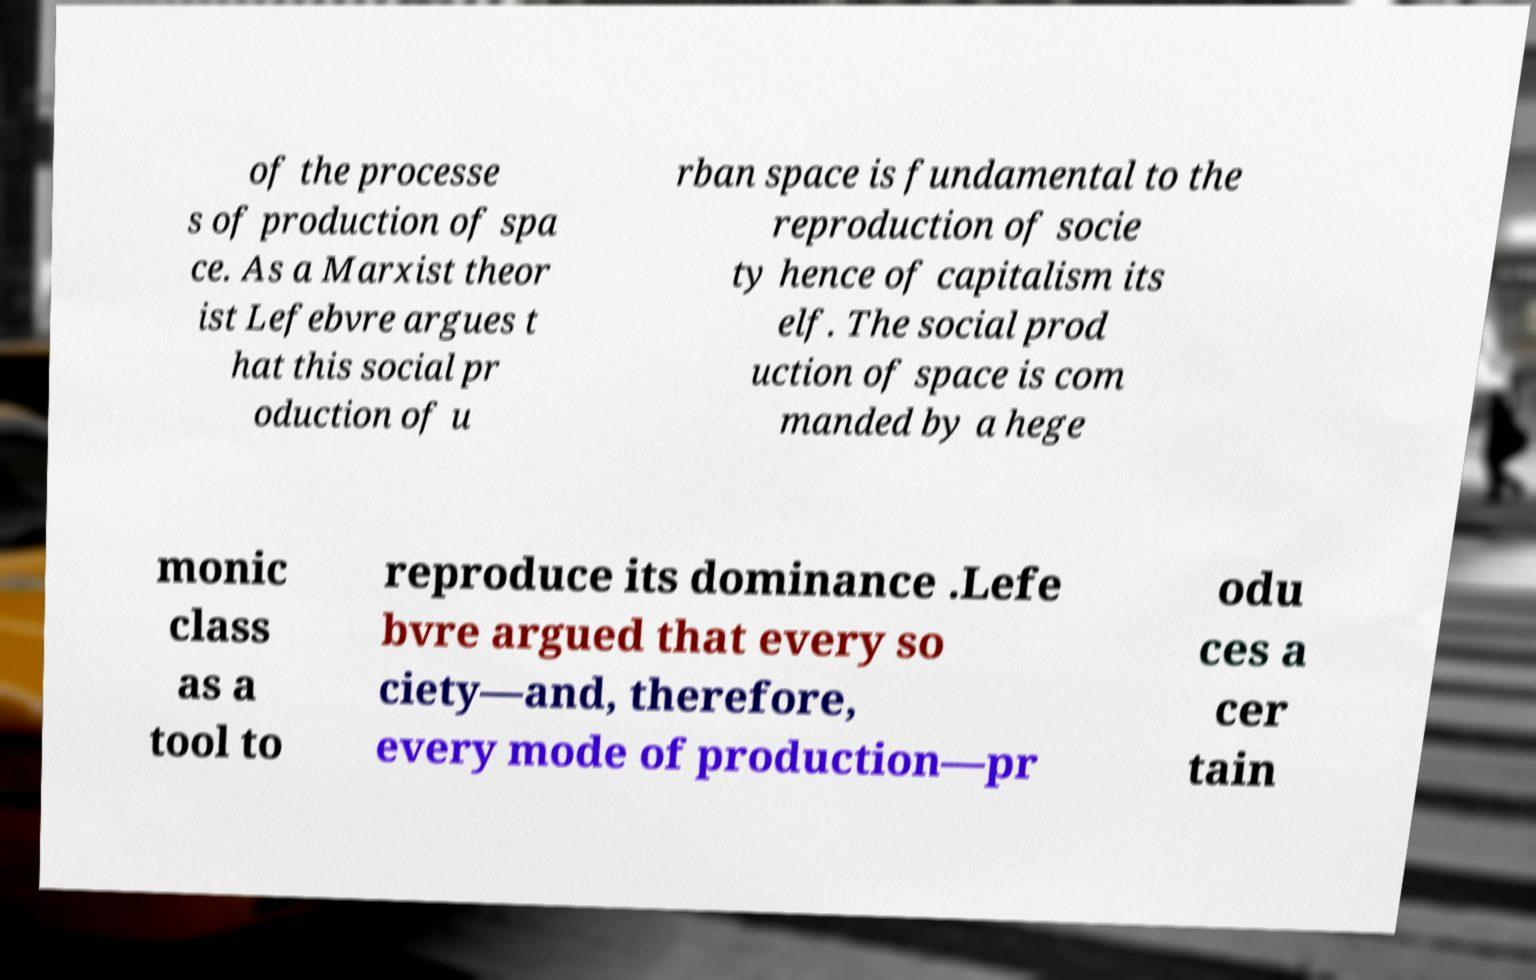Could you assist in decoding the text presented in this image and type it out clearly? of the processe s of production of spa ce. As a Marxist theor ist Lefebvre argues t hat this social pr oduction of u rban space is fundamental to the reproduction of socie ty hence of capitalism its elf. The social prod uction of space is com manded by a hege monic class as a tool to reproduce its dominance .Lefe bvre argued that every so ciety—and, therefore, every mode of production—pr odu ces a cer tain 